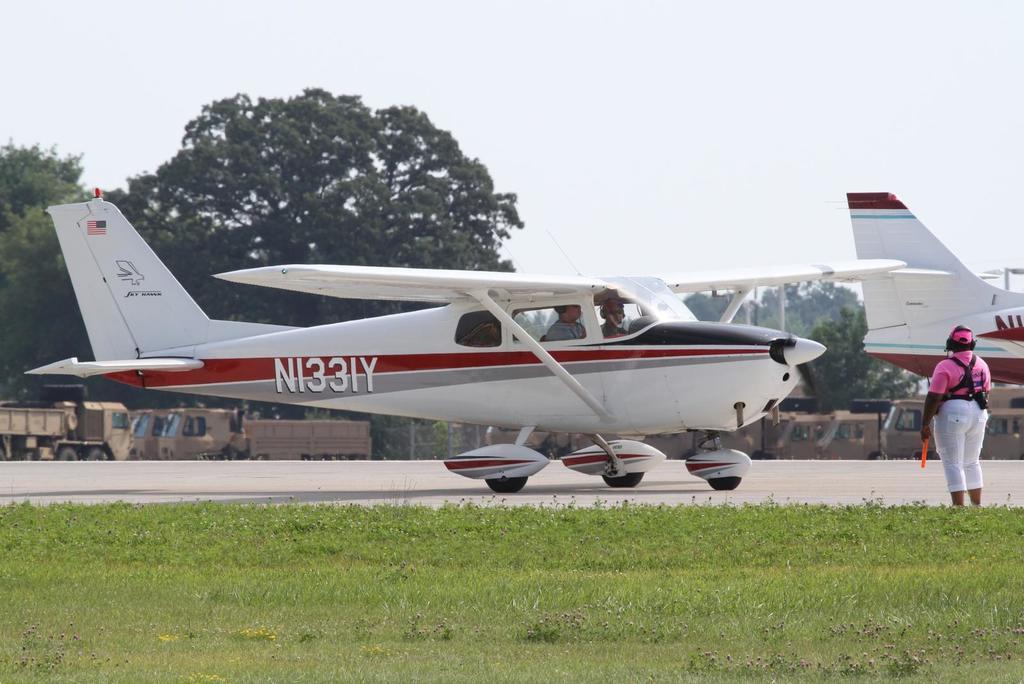Can you describe this image briefly? In this image we can see few aircraft. There is some text and few logos on the aircraft. We can see few people in the image. A person is standing and holding an object at the right side of the image. We can see the sky in the image. There are few vehicles at the left side of the image. There are few vehicles at the right side of the image. There is a grassy land in the image. 